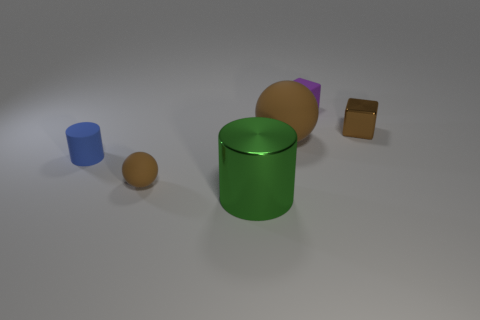Can you describe the positions of the objects relative to the green cylinder? Certainly! To the left of the green cylinder, there is a small blue cylinder and a small orange sphere closely placed together. On the right, distanced from the green cylinder, there are a small purple block and a small brown metallic cube. 